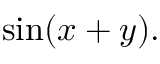Convert formula to latex. <formula><loc_0><loc_0><loc_500><loc_500>\sin ( x + y ) .</formula> 